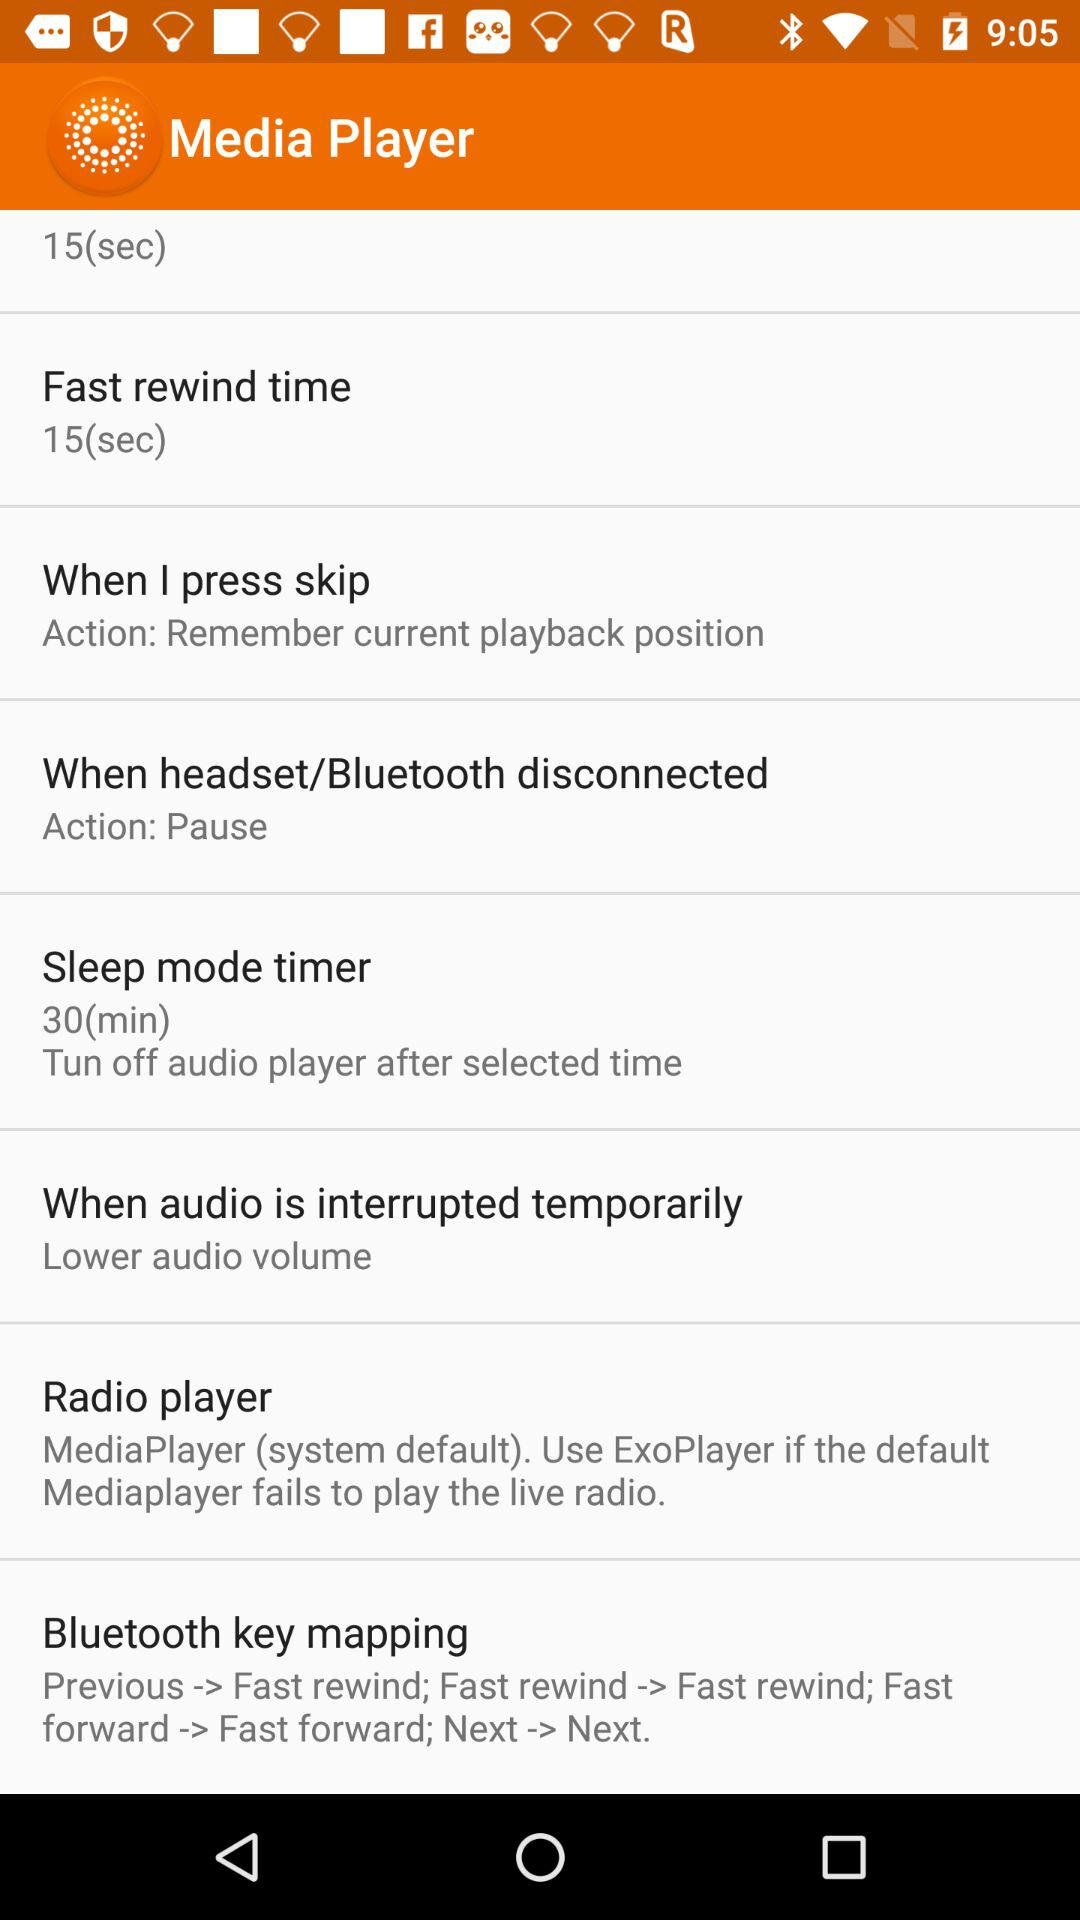What can I do when audio is interrupted temporarily? You can lower the audio volume. 